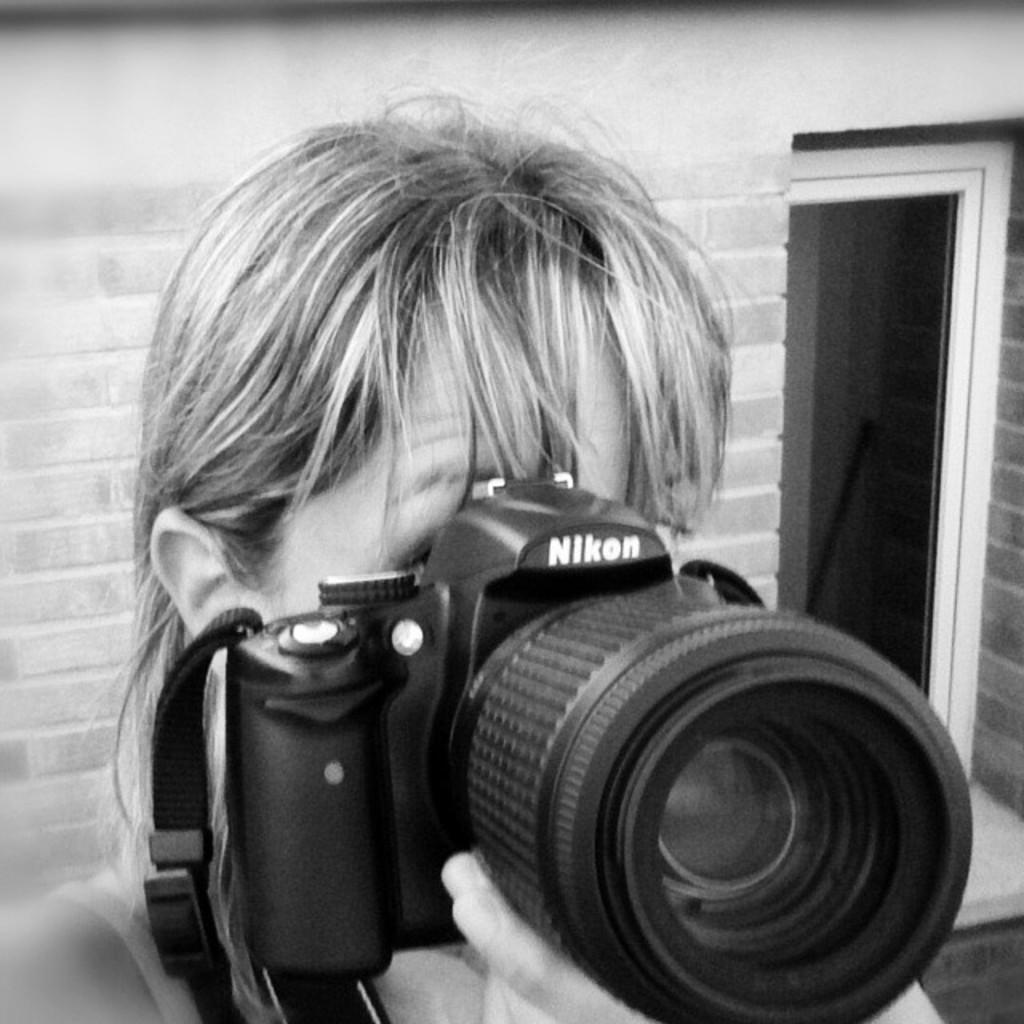Could you give a brief overview of what you see in this image? Girl is holding a camera with her hand there is a text on the Camera Nikon behind her there is a brick wall. 